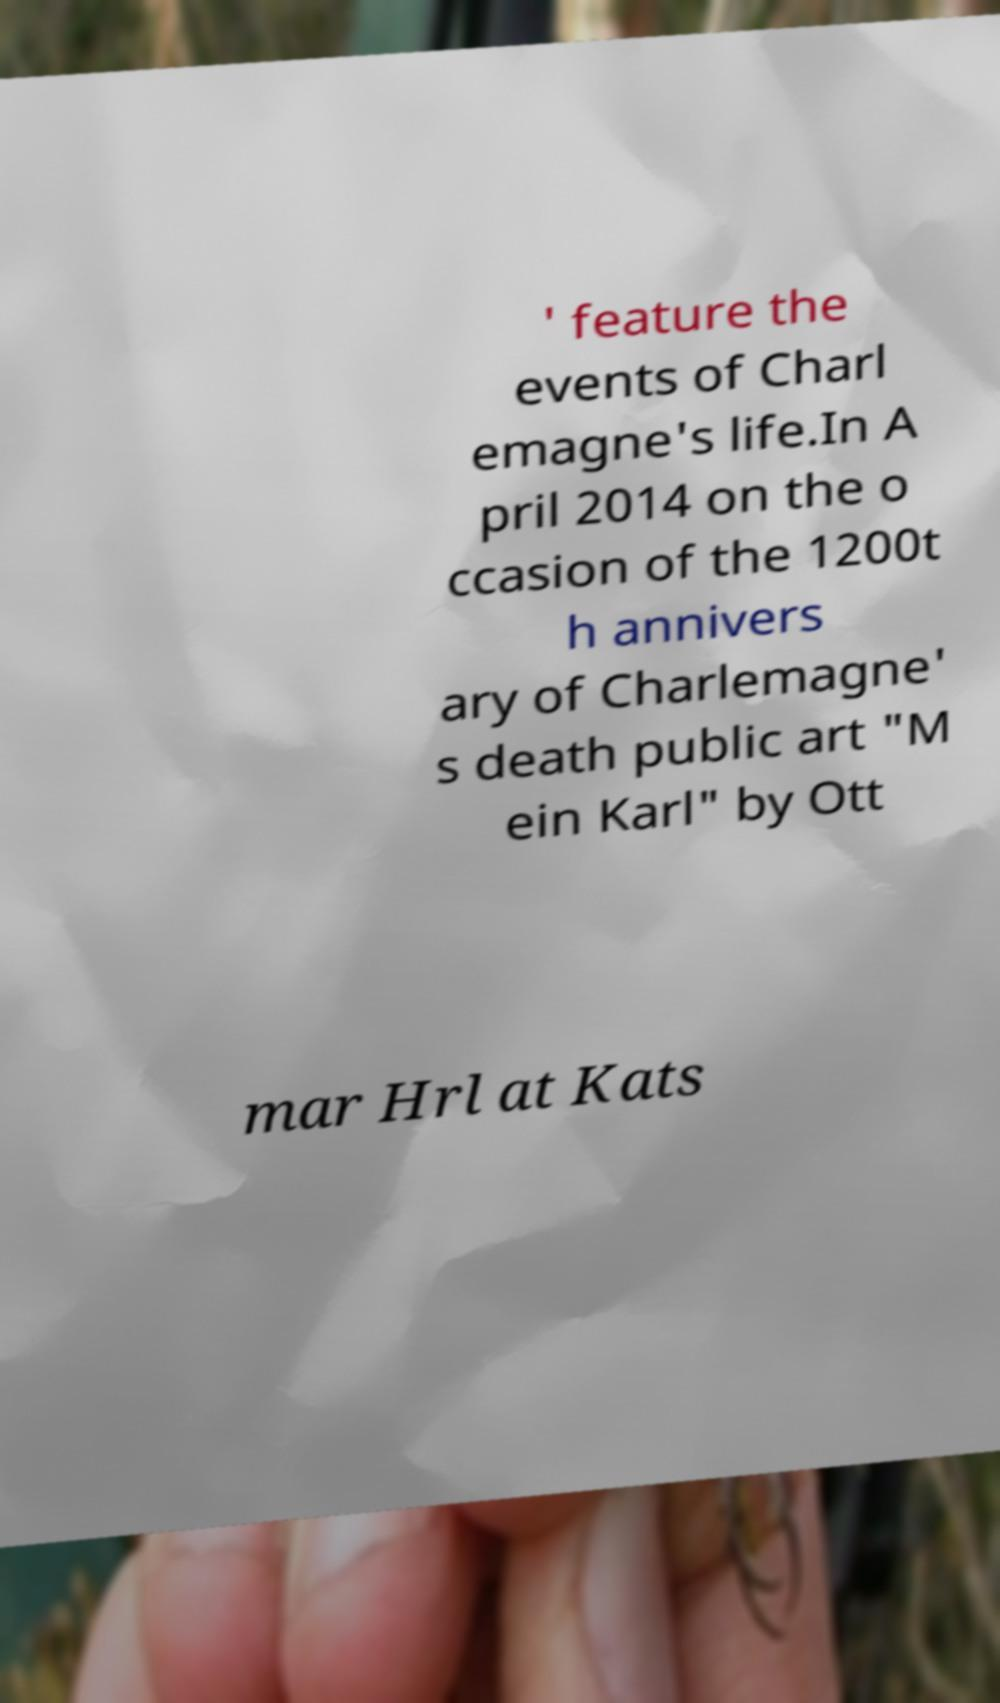What messages or text are displayed in this image? I need them in a readable, typed format. ' feature the events of Charl emagne's life.In A pril 2014 on the o ccasion of the 1200t h annivers ary of Charlemagne' s death public art "M ein Karl" by Ott mar Hrl at Kats 